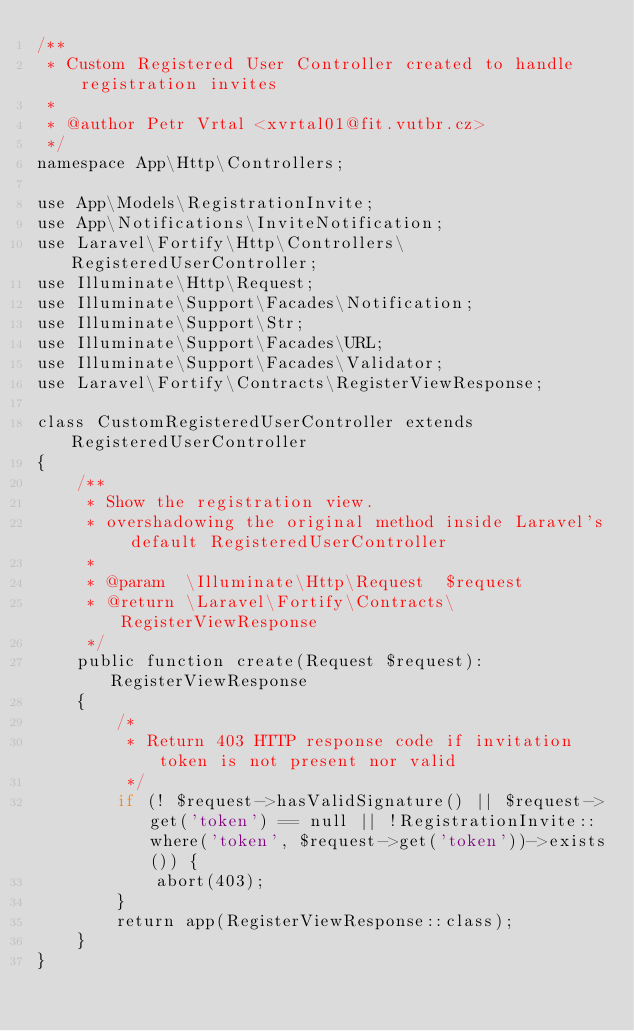Convert code to text. <code><loc_0><loc_0><loc_500><loc_500><_PHP_>/**
 * Custom Registered User Controller created to handle registration invites
 *
 * @author Petr Vrtal <xvrtal01@fit.vutbr.cz>
 */
namespace App\Http\Controllers;

use App\Models\RegistrationInvite;
use App\Notifications\InviteNotification;
use Laravel\Fortify\Http\Controllers\RegisteredUserController;
use Illuminate\Http\Request;
use Illuminate\Support\Facades\Notification;
use Illuminate\Support\Str;
use Illuminate\Support\Facades\URL;
use Illuminate\Support\Facades\Validator;
use Laravel\Fortify\Contracts\RegisterViewResponse;

class CustomRegisteredUserController extends RegisteredUserController
{
    /**
     * Show the registration view.
     * overshadowing the original method inside Laravel's default RegisteredUserController
     *
     * @param  \Illuminate\Http\Request  $request
     * @return \Laravel\Fortify\Contracts\RegisterViewResponse
     */
    public function create(Request $request): RegisterViewResponse
    {
        /*
         * Return 403 HTTP response code if invitation token is not present nor valid
         */
        if (! $request->hasValidSignature() || $request->get('token') == null || !RegistrationInvite::where('token', $request->get('token'))->exists()) {
            abort(403);
        }
        return app(RegisterViewResponse::class);
    }
}
</code> 